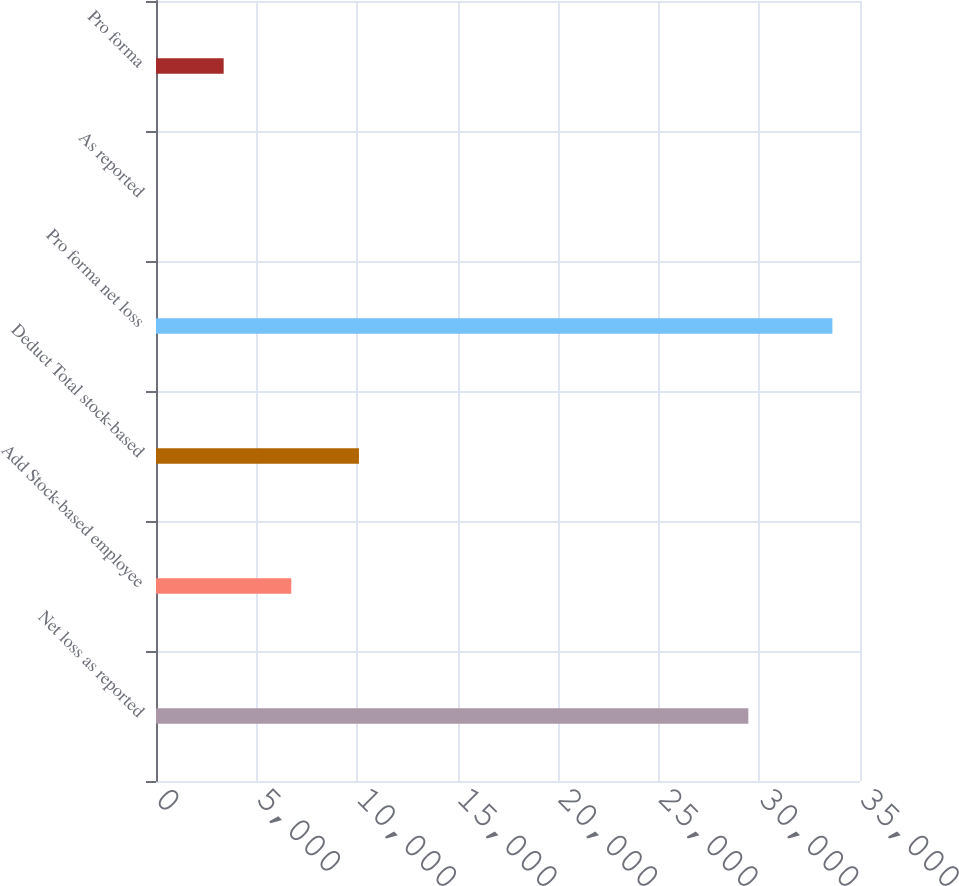Convert chart to OTSL. <chart><loc_0><loc_0><loc_500><loc_500><bar_chart><fcel>Net loss as reported<fcel>Add Stock-based employee<fcel>Deduct Total stock-based<fcel>Pro forma net loss<fcel>As reported<fcel>Pro forma<nl><fcel>29449<fcel>6726.52<fcel>10089.2<fcel>33628<fcel>1.15<fcel>3363.84<nl></chart> 